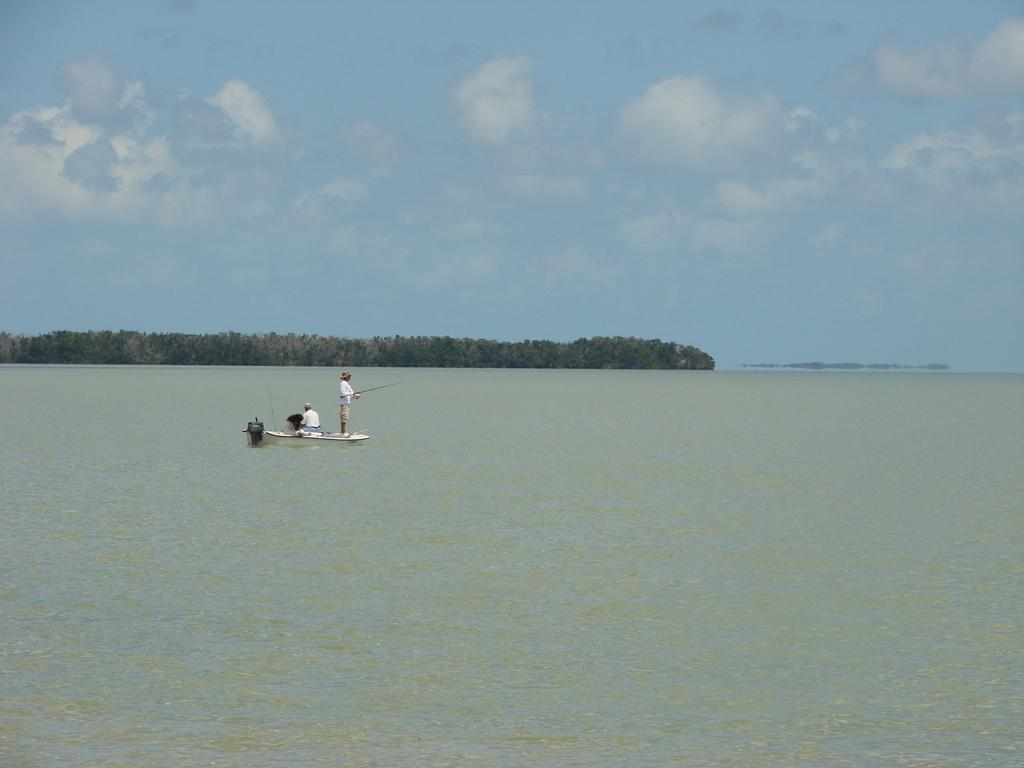What are the people in the image doing? The people in the image are sailing in a boat. What is the person holding in the image? One person is holding an object. What type of environment is visible in the image? There is water, trees, and the sky visible in the image. What can be seen in the sky in the image? Clouds are present in the sky. How does the boat maintain its balance while the bulb is turned on in the image? There is no bulb present in the image, and therefore no such activity can be observed. 